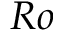<formula> <loc_0><loc_0><loc_500><loc_500>R o</formula> 